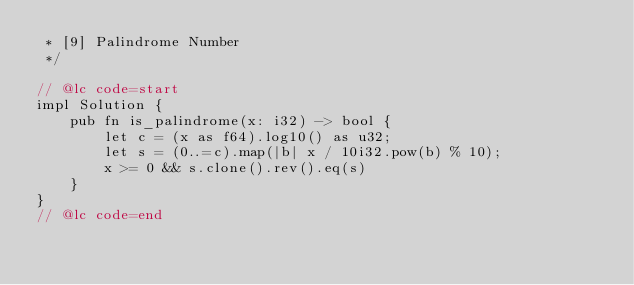Convert code to text. <code><loc_0><loc_0><loc_500><loc_500><_Rust_> * [9] Palindrome Number
 */

// @lc code=start
impl Solution {
    pub fn is_palindrome(x: i32) -> bool {
        let c = (x as f64).log10() as u32;
        let s = (0..=c).map(|b| x / 10i32.pow(b) % 10);
        x >= 0 && s.clone().rev().eq(s)
    }
}
// @lc code=end
</code> 